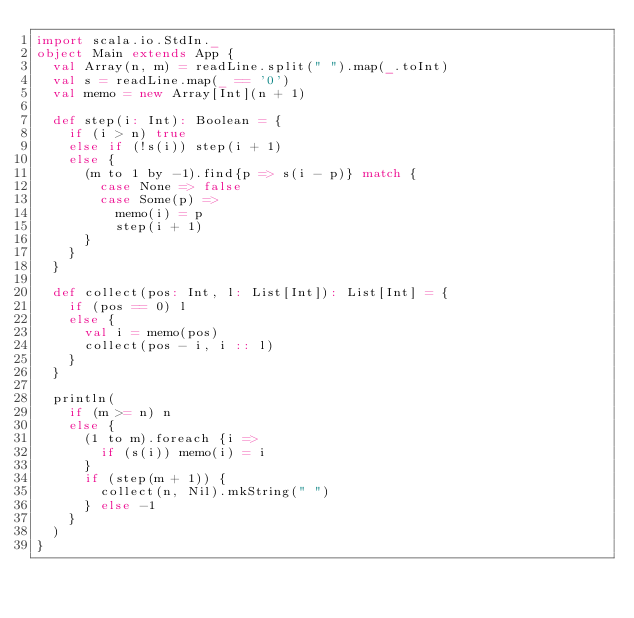Convert code to text. <code><loc_0><loc_0><loc_500><loc_500><_Scala_>import scala.io.StdIn._
object Main extends App {
  val Array(n, m) = readLine.split(" ").map(_.toInt)
  val s = readLine.map(_ == '0')
  val memo = new Array[Int](n + 1)

  def step(i: Int): Boolean = {
    if (i > n) true
    else if (!s(i)) step(i + 1)
    else {
      (m to 1 by -1).find{p => s(i - p)} match {
        case None => false
        case Some(p) =>
          memo(i) = p
          step(i + 1)
      }
    }
  }

  def collect(pos: Int, l: List[Int]): List[Int] = {
    if (pos == 0) l
    else {
      val i = memo(pos)
      collect(pos - i, i :: l)
    }
  }

  println(
    if (m >= n) n
    else {
      (1 to m).foreach {i =>
        if (s(i)) memo(i) = i
      }
      if (step(m + 1)) {
        collect(n, Nil).mkString(" ")
      } else -1
    }
  )
}</code> 